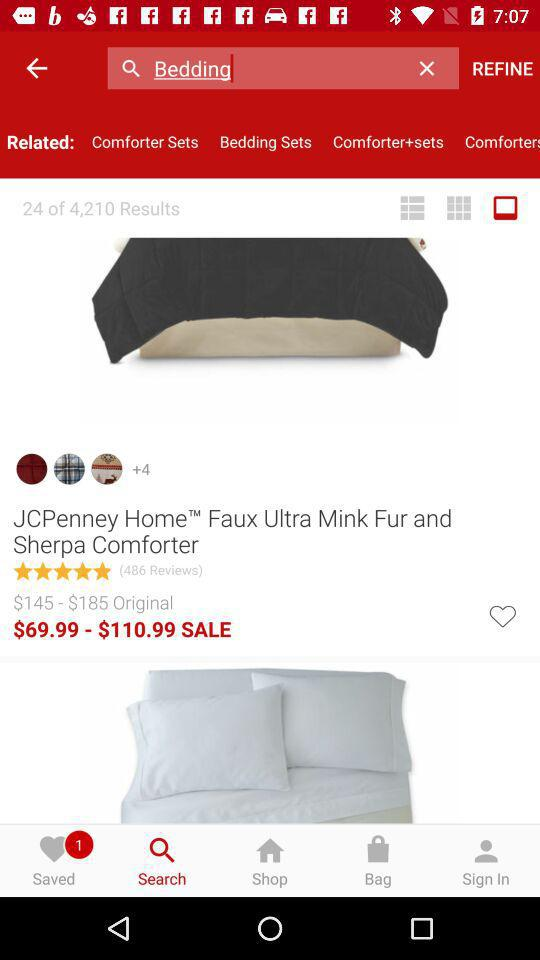What is the sale price of the "JCPenney Home Faux Ultra Mink Fur and Sherpa Comforter"? The price ranges from $69.99 to $110.99. 